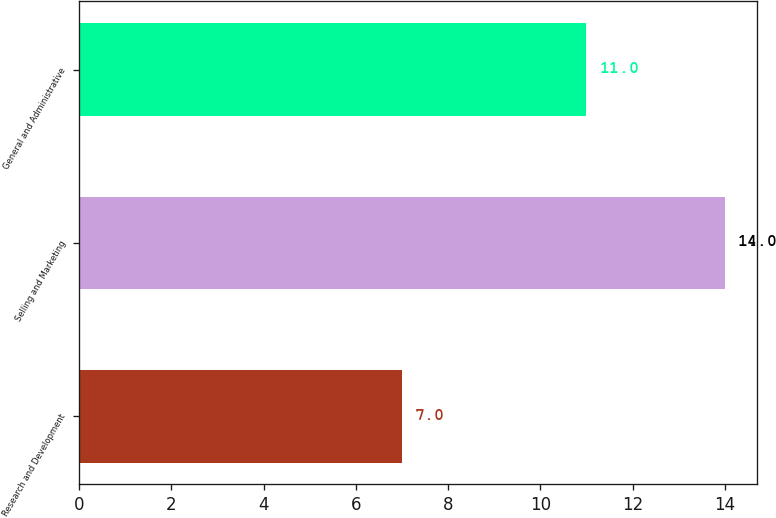Convert chart to OTSL. <chart><loc_0><loc_0><loc_500><loc_500><bar_chart><fcel>Research and Development<fcel>Selling and Marketing<fcel>General and Administrative<nl><fcel>7<fcel>14<fcel>11<nl></chart> 